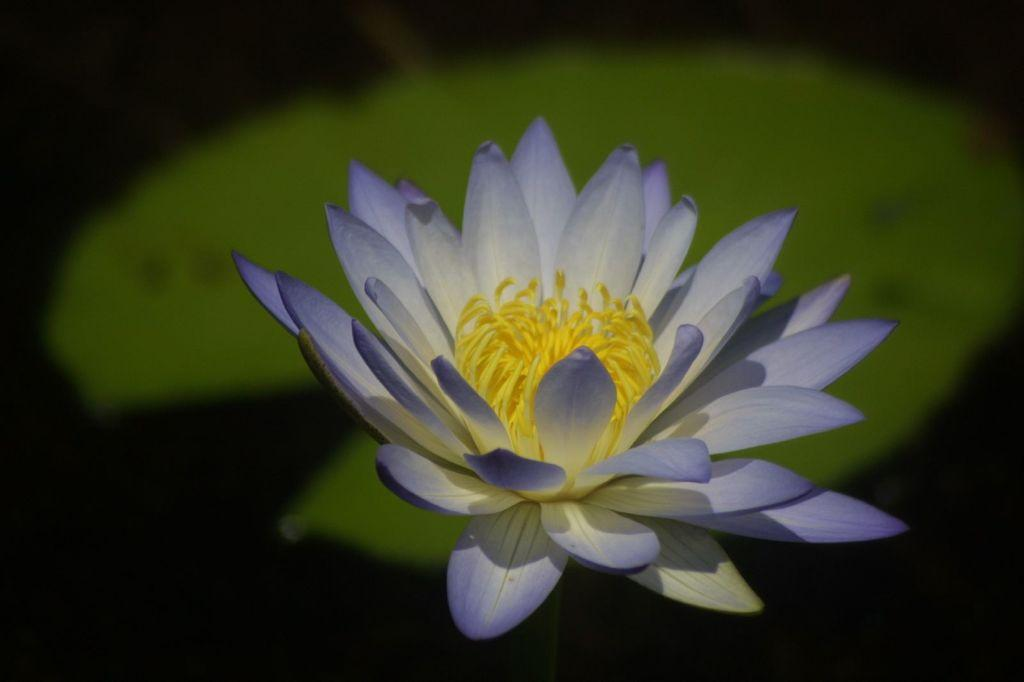What type of flower is in the image? There is a blue lotus in the image. Does the blue lotus have any other parts besides the flower? Yes, the blue lotus has a leaf. What is the color of the background in the image? The background of the image is dark. What is the name of the person holding the thumb in the image? There is no person or thumb present in the image; it features a blue lotus with a leaf and a dark background. 